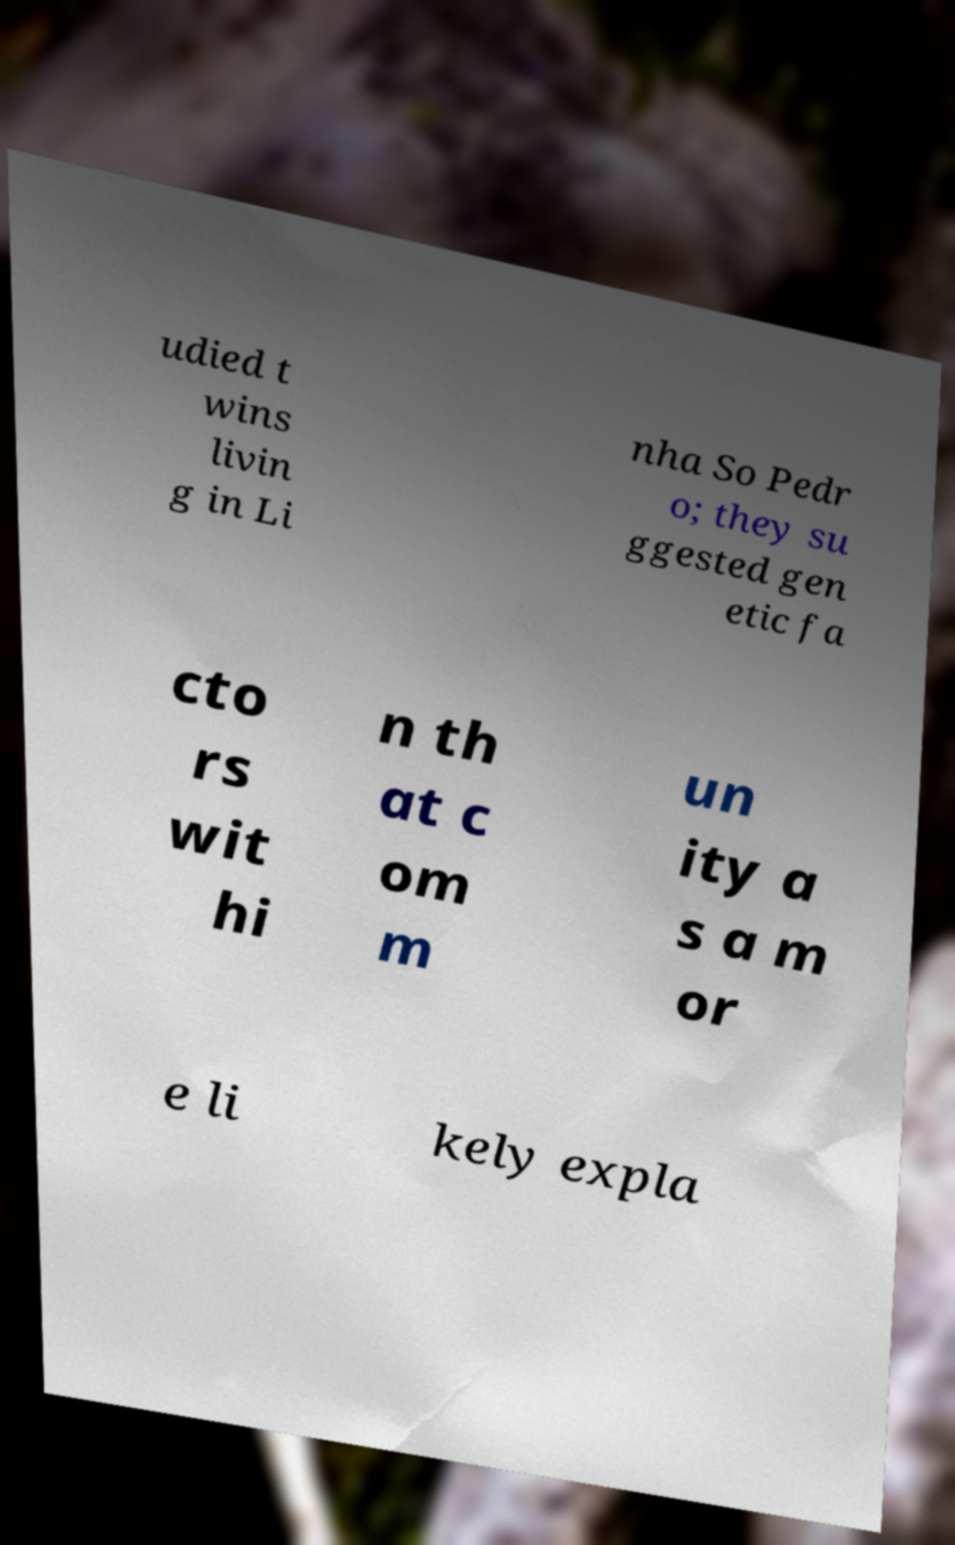Can you read and provide the text displayed in the image?This photo seems to have some interesting text. Can you extract and type it out for me? udied t wins livin g in Li nha So Pedr o; they su ggested gen etic fa cto rs wit hi n th at c om m un ity a s a m or e li kely expla 